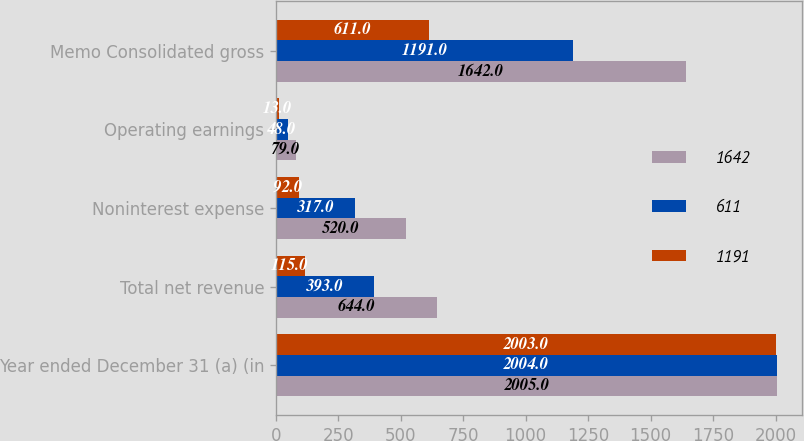Convert chart to OTSL. <chart><loc_0><loc_0><loc_500><loc_500><stacked_bar_chart><ecel><fcel>Year ended December 31 (a) (in<fcel>Total net revenue<fcel>Noninterest expense<fcel>Operating earnings<fcel>Memo Consolidated gross<nl><fcel>1642<fcel>2005<fcel>644<fcel>520<fcel>79<fcel>1642<nl><fcel>611<fcel>2004<fcel>393<fcel>317<fcel>48<fcel>1191<nl><fcel>1191<fcel>2003<fcel>115<fcel>92<fcel>13<fcel>611<nl></chart> 